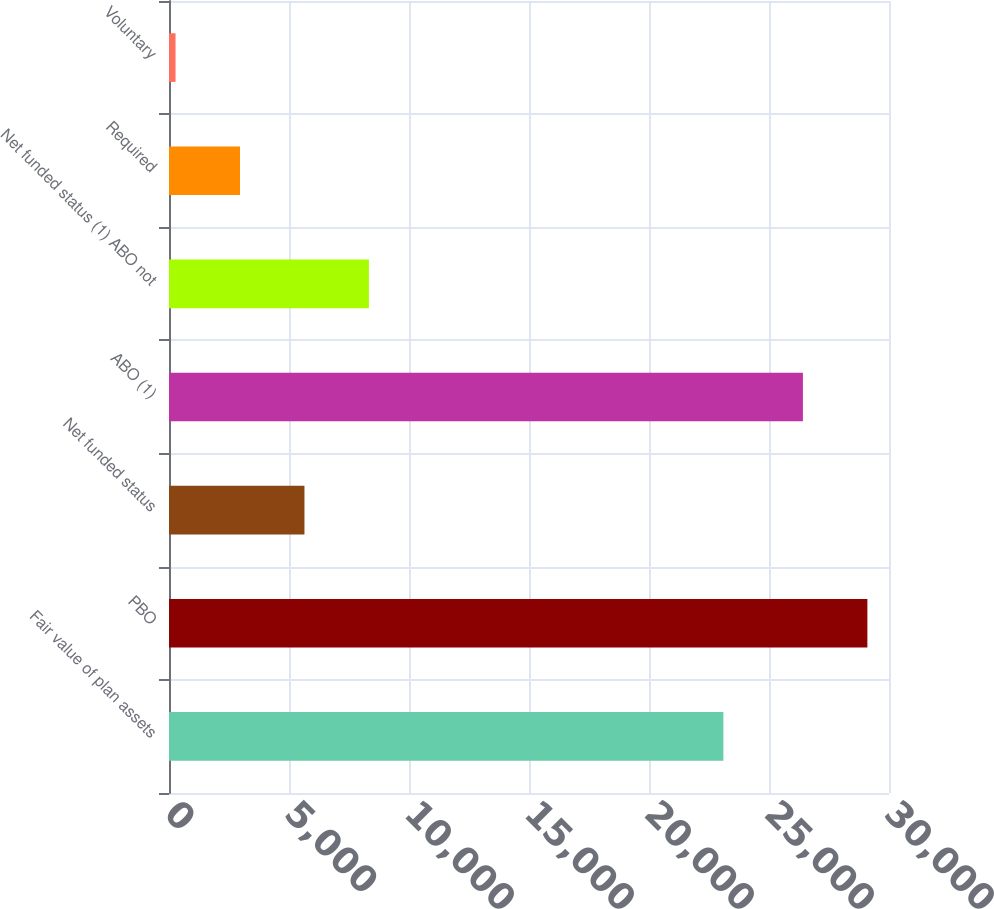Convert chart to OTSL. <chart><loc_0><loc_0><loc_500><loc_500><bar_chart><fcel>Fair value of plan assets<fcel>PBO<fcel>Net funded status<fcel>ABO (1)<fcel>Net funded status (1) ABO not<fcel>Required<fcel>Voluntary<nl><fcel>23099<fcel>29099<fcel>5644<fcel>26413<fcel>8330<fcel>2958<fcel>272<nl></chart> 